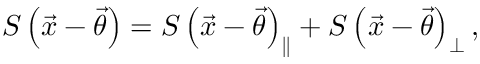Convert formula to latex. <formula><loc_0><loc_0><loc_500><loc_500>S \left ( \vec { x } - \vec { \theta } \right ) = S \left ( \vec { x } - \vec { \theta } \right ) _ { \| } + S \left ( \vec { x } - \vec { \theta } \right ) _ { \perp } ,</formula> 